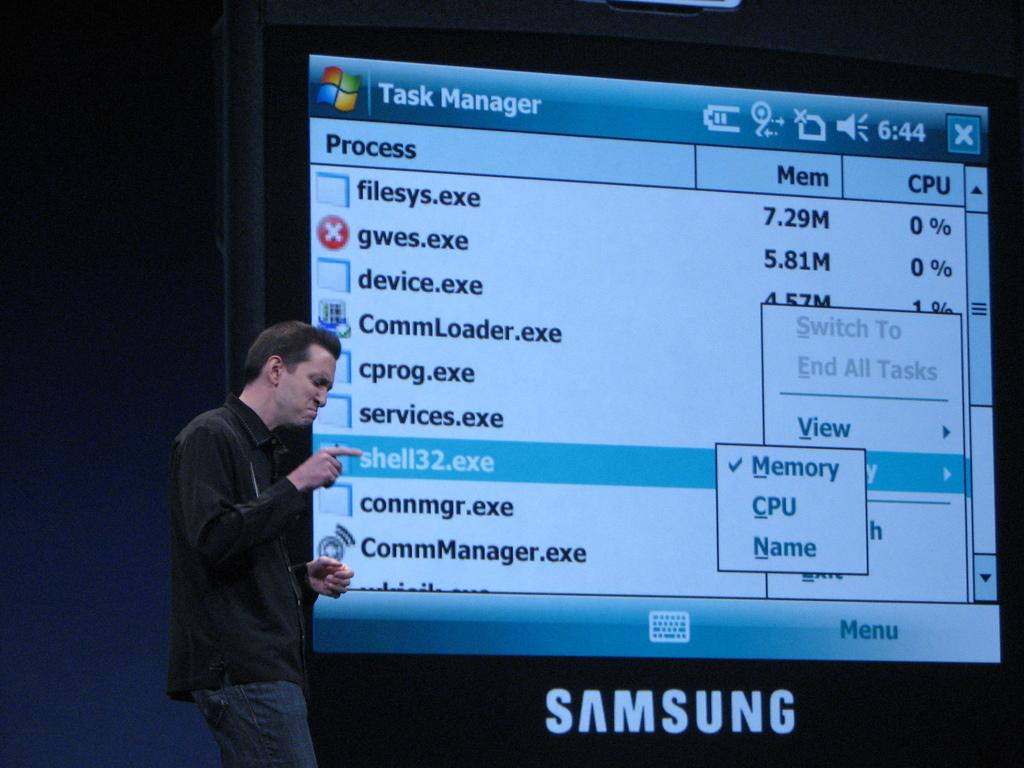What is the main subject of the image? There is a person in the image. What is the person wearing? The person is wearing a black shirt and blue jeans. What is the person's posture in the image? The person is standing. What can be seen in the background of the image? There is a huge screen in the background of the image. What type of plough is being used in the image? There is no plough present in the image. What kind of drug is the person holding in the image? There is no drug present in the image. 